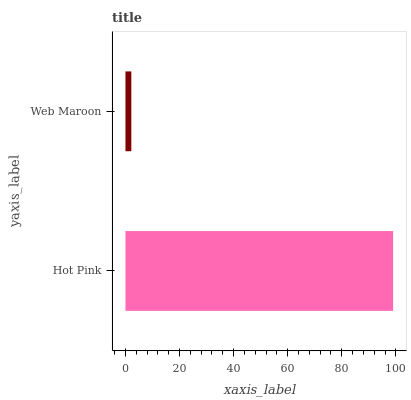Is Web Maroon the minimum?
Answer yes or no. Yes. Is Hot Pink the maximum?
Answer yes or no. Yes. Is Web Maroon the maximum?
Answer yes or no. No. Is Hot Pink greater than Web Maroon?
Answer yes or no. Yes. Is Web Maroon less than Hot Pink?
Answer yes or no. Yes. Is Web Maroon greater than Hot Pink?
Answer yes or no. No. Is Hot Pink less than Web Maroon?
Answer yes or no. No. Is Hot Pink the high median?
Answer yes or no. Yes. Is Web Maroon the low median?
Answer yes or no. Yes. Is Web Maroon the high median?
Answer yes or no. No. Is Hot Pink the low median?
Answer yes or no. No. 